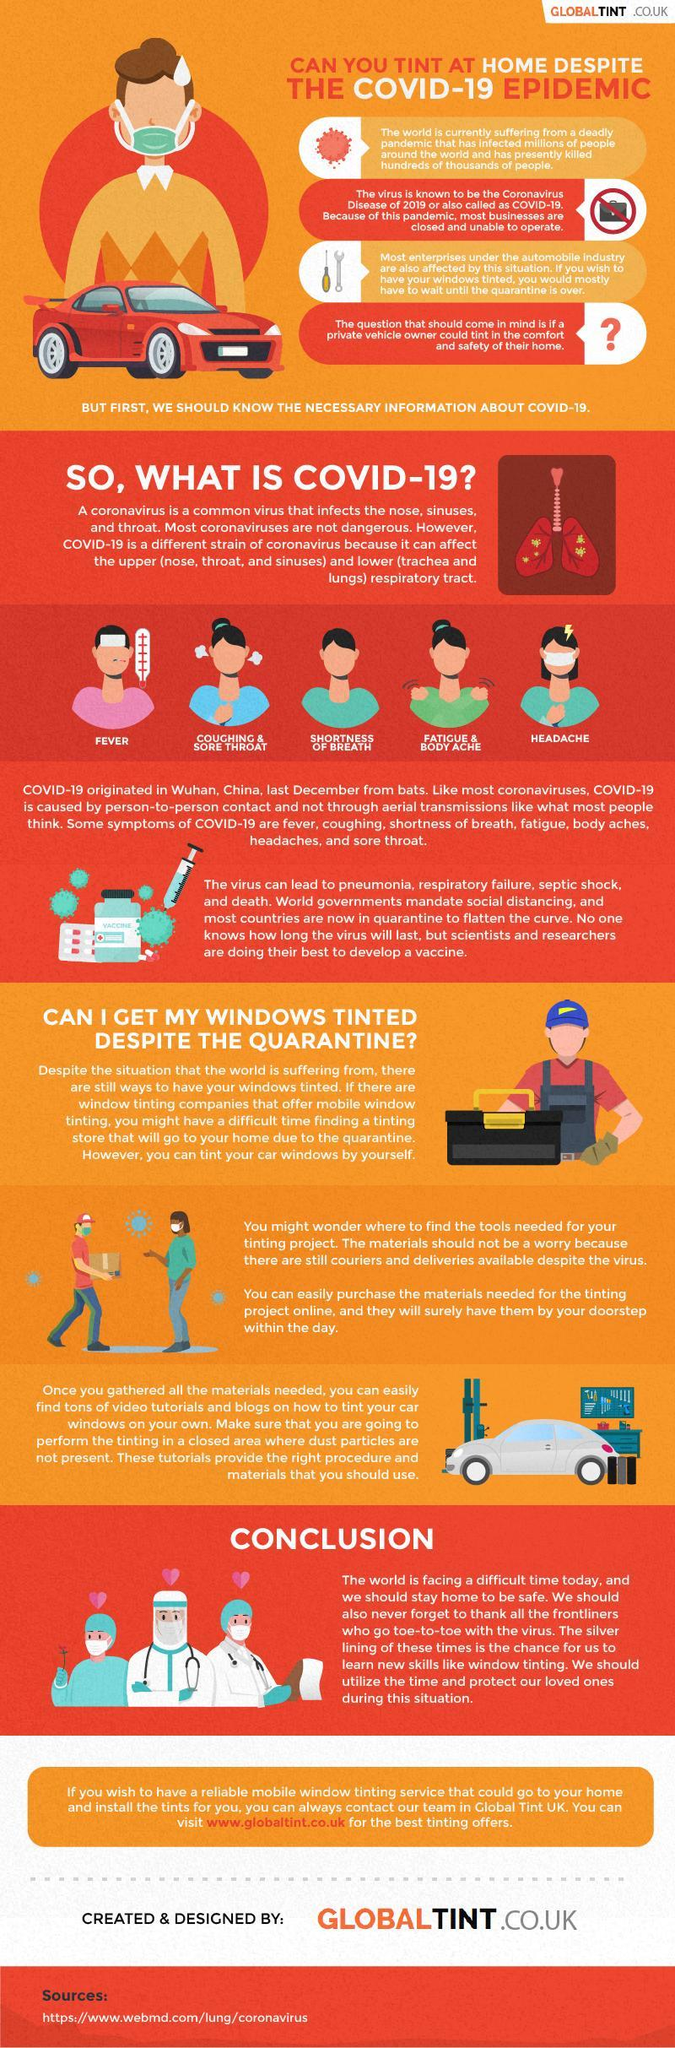Where was the first case of COVID-19 reported?
Answer the question with a short phrase. Wuhan, China 